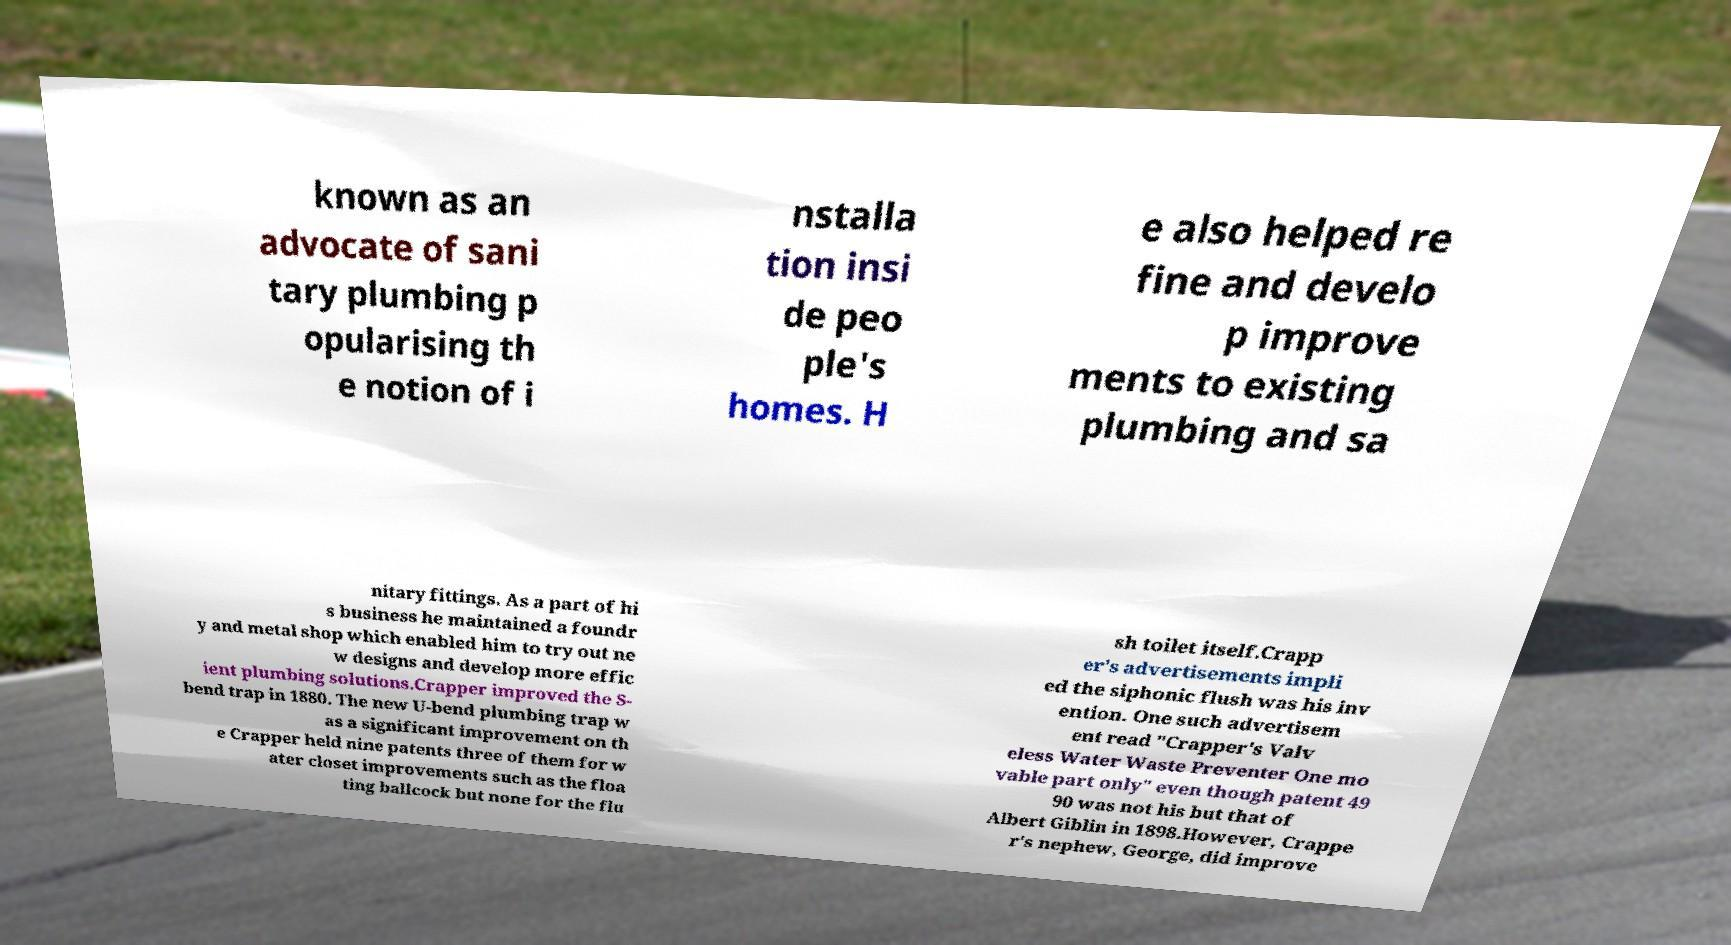Can you accurately transcribe the text from the provided image for me? known as an advocate of sani tary plumbing p opularising th e notion of i nstalla tion insi de peo ple's homes. H e also helped re fine and develo p improve ments to existing plumbing and sa nitary fittings. As a part of hi s business he maintained a foundr y and metal shop which enabled him to try out ne w designs and develop more effic ient plumbing solutions.Crapper improved the S- bend trap in 1880. The new U-bend plumbing trap w as a significant improvement on th e Crapper held nine patents three of them for w ater closet improvements such as the floa ting ballcock but none for the flu sh toilet itself.Crapp er's advertisements impli ed the siphonic flush was his inv ention. One such advertisem ent read "Crapper's Valv eless Water Waste Preventer One mo vable part only" even though patent 49 90 was not his but that of Albert Giblin in 1898.However, Crappe r's nephew, George, did improve 